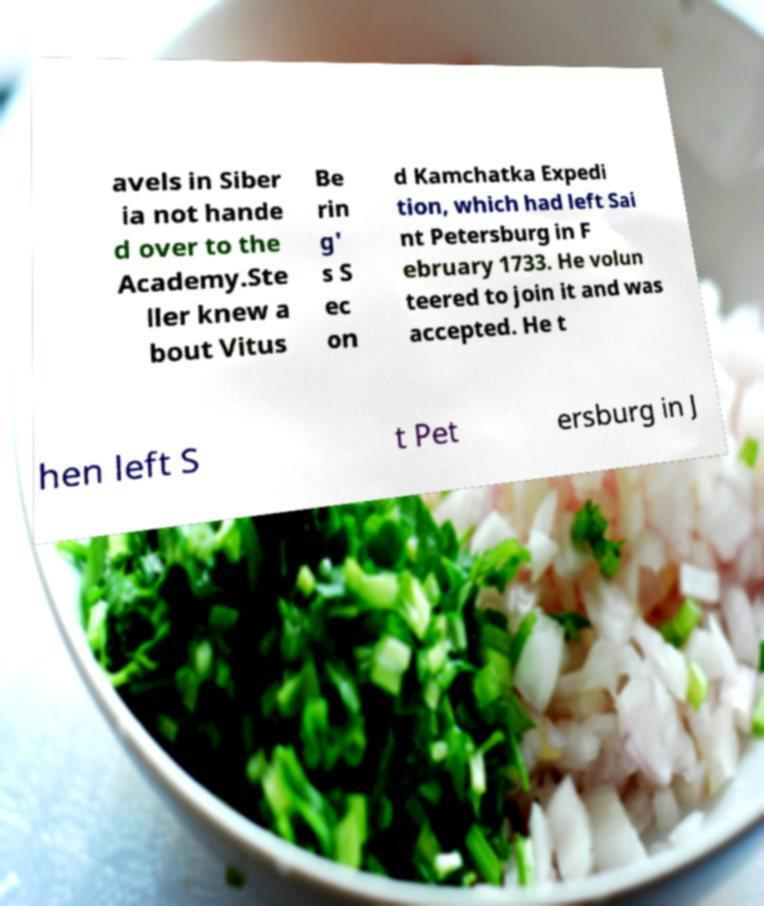Could you assist in decoding the text presented in this image and type it out clearly? avels in Siber ia not hande d over to the Academy.Ste ller knew a bout Vitus Be rin g' s S ec on d Kamchatka Expedi tion, which had left Sai nt Petersburg in F ebruary 1733. He volun teered to join it and was accepted. He t hen left S t Pet ersburg in J 